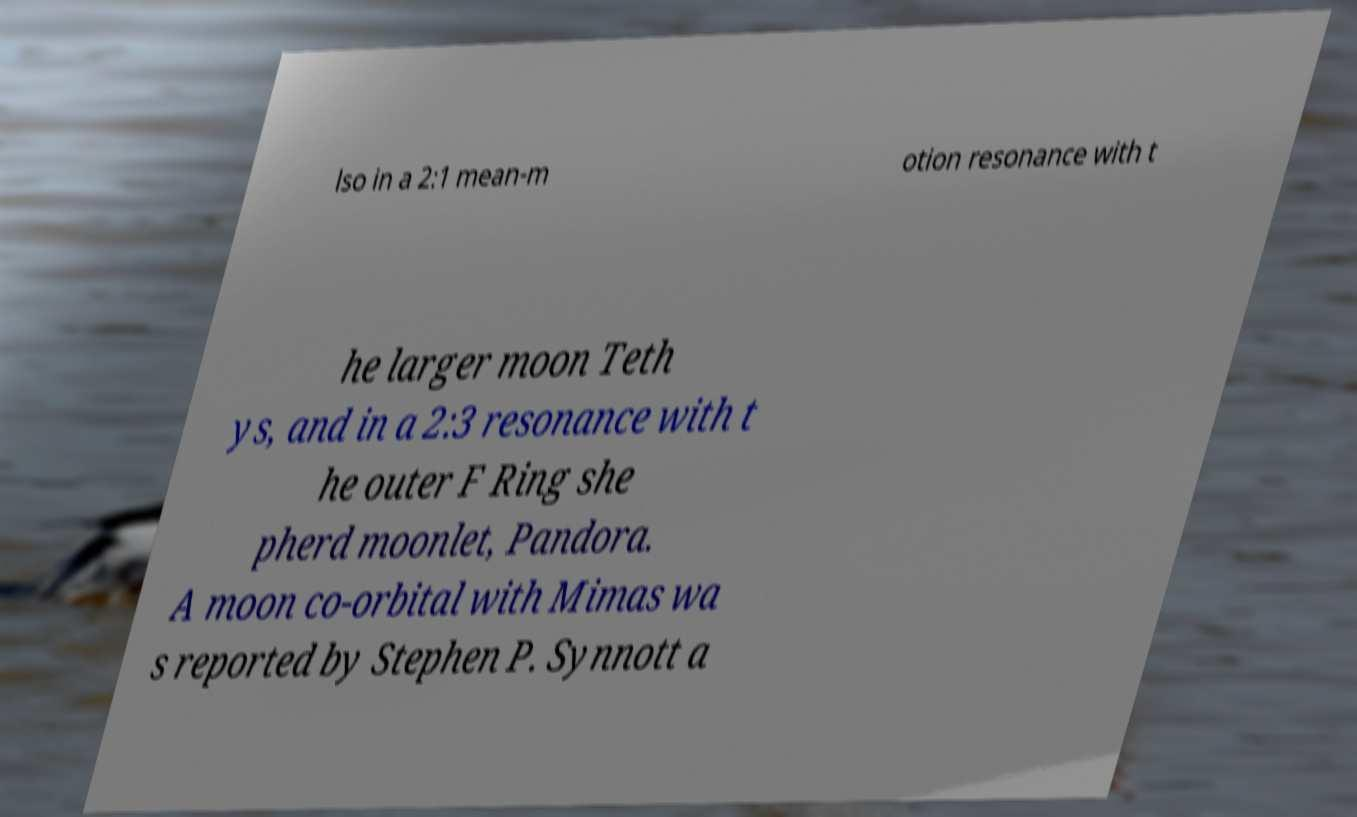Please read and relay the text visible in this image. What does it say? lso in a 2:1 mean-m otion resonance with t he larger moon Teth ys, and in a 2:3 resonance with t he outer F Ring she pherd moonlet, Pandora. A moon co-orbital with Mimas wa s reported by Stephen P. Synnott a 